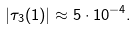Convert formula to latex. <formula><loc_0><loc_0><loc_500><loc_500>| \tau _ { 3 } ( 1 ) | \approx 5 \cdot 1 0 ^ { - 4 } .</formula> 